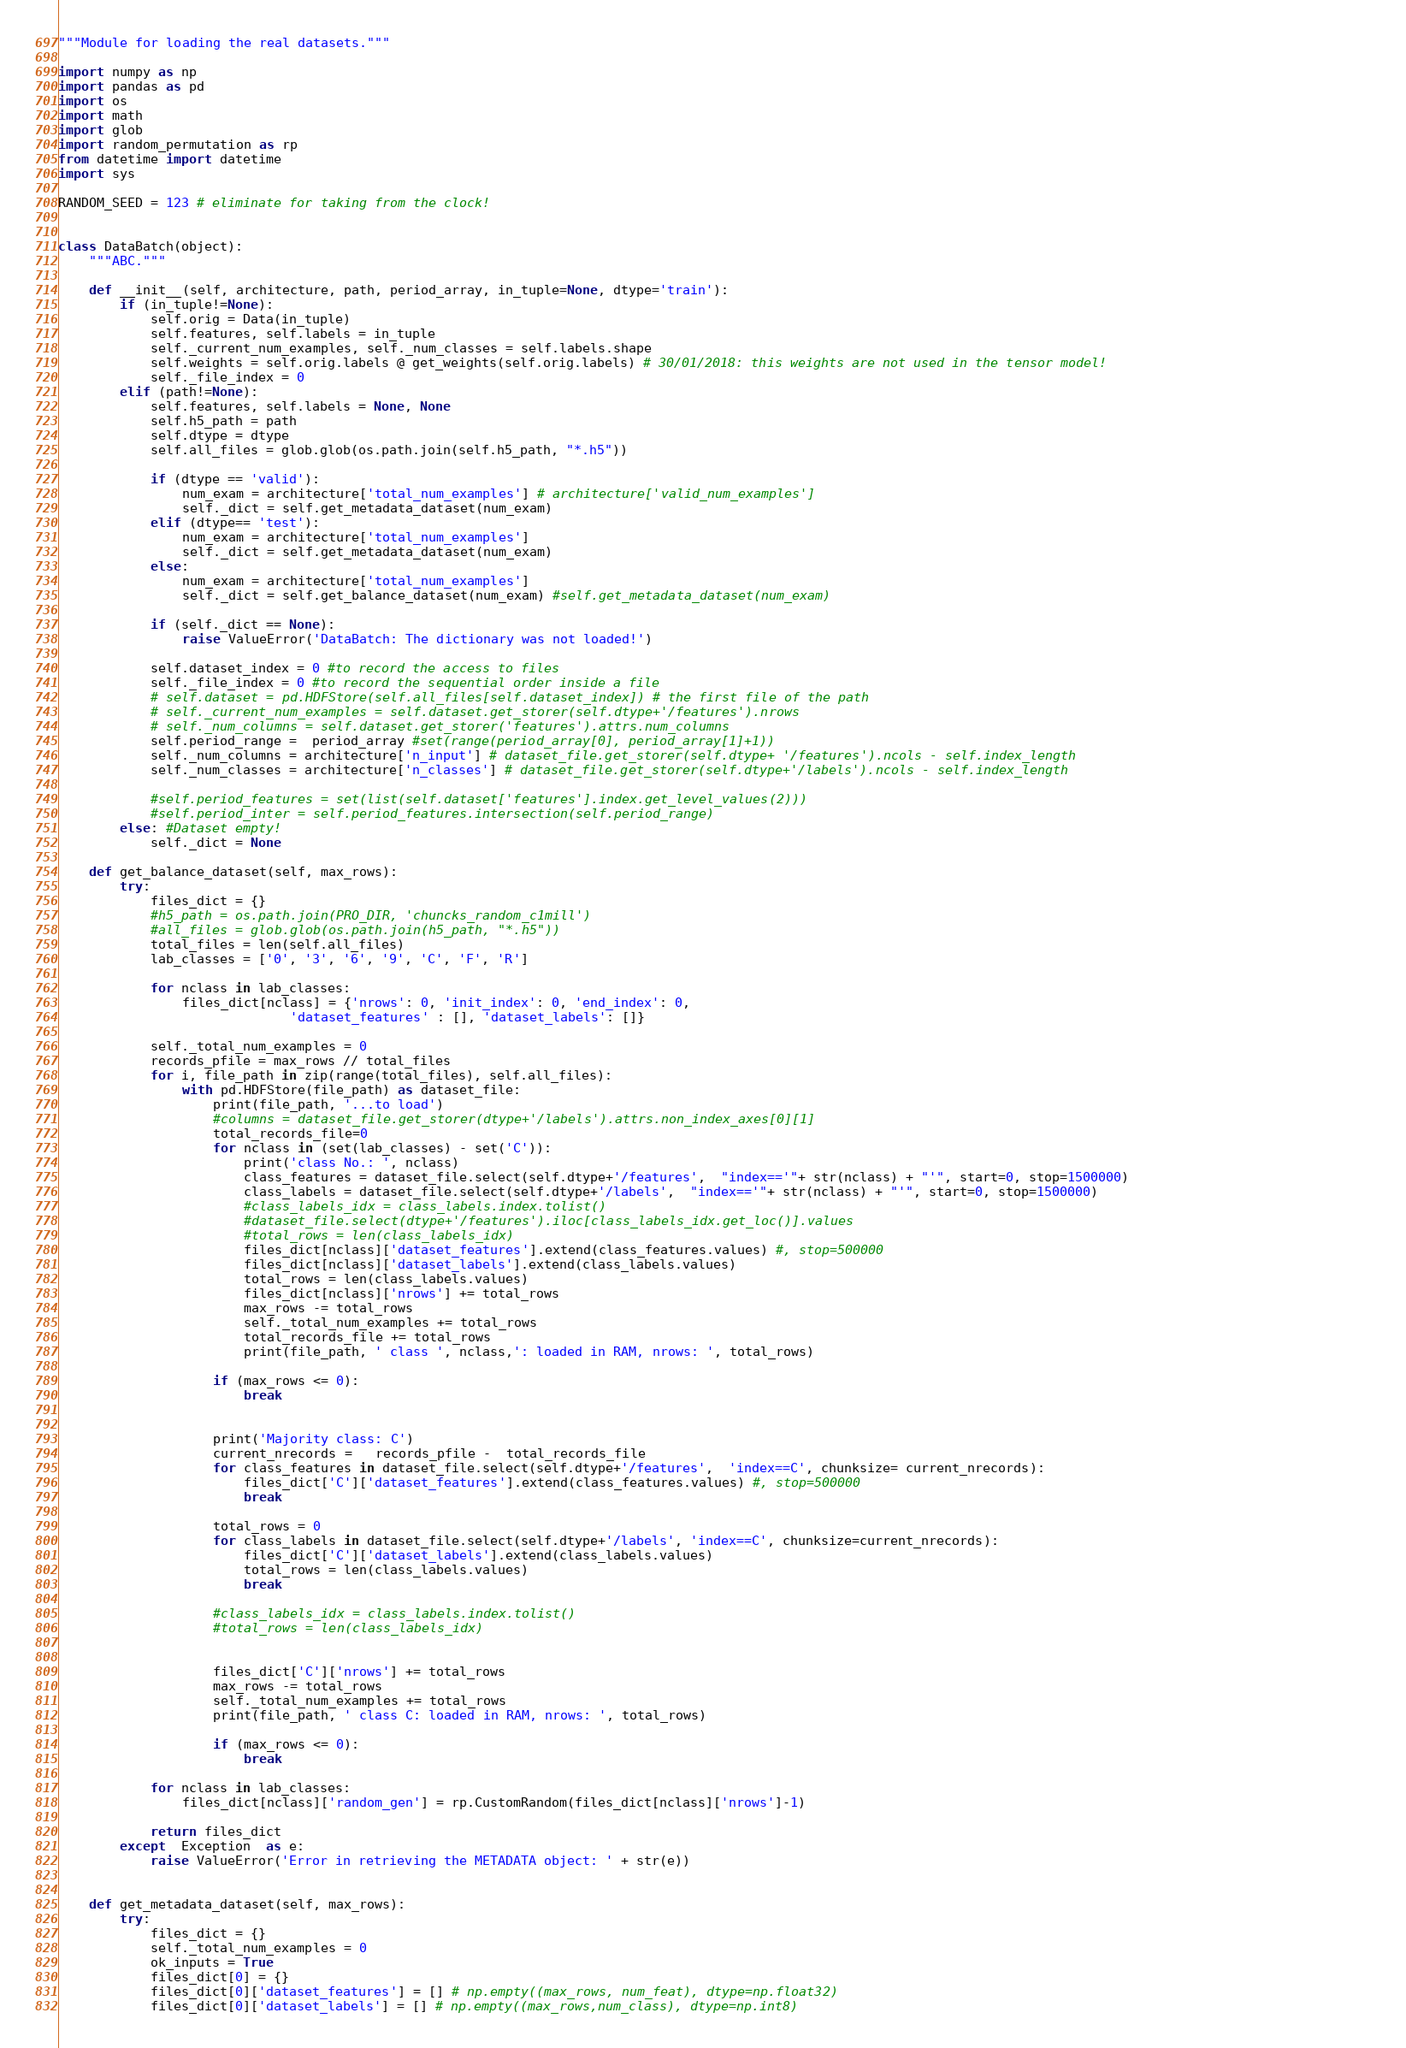Convert code to text. <code><loc_0><loc_0><loc_500><loc_500><_Python_>"""Module for loading the real datasets."""

import numpy as np
import pandas as pd
import os
import math
import glob
import random_permutation as rp
from datetime import datetime
import sys

RANDOM_SEED = 123 # eliminate for taking from the clock!


class DataBatch(object):
    """ABC."""

    def __init__(self, architecture, path, period_array, in_tuple=None, dtype='train'):
        if (in_tuple!=None):
            self.orig = Data(in_tuple)
            self.features, self.labels = in_tuple
            self._current_num_examples, self._num_classes = self.labels.shape        
            self.weights = self.orig.labels @ get_weights(self.orig.labels) # 30/01/2018: this weights are not used in the tensor model!
            self._file_index = 0            
        elif (path!=None):            
            self.features, self.labels = None, None
            self.h5_path = path
            self.dtype = dtype            
            self.all_files = glob.glob(os.path.join(self.h5_path, "*.h5"))    

            if (dtype == 'valid'):
                num_exam = architecture['total_num_examples'] # architecture['valid_num_examples']
                self._dict = self.get_metadata_dataset(num_exam)
            elif (dtype== 'test'):
                num_exam = architecture['total_num_examples']
                self._dict = self.get_metadata_dataset(num_exam)
            else:
                num_exam = architecture['total_num_examples']
                self._dict = self.get_balance_dataset(num_exam) #self.get_metadata_dataset(num_exam)
                                                
            if (self._dict == None):
                raise ValueError('DataBatch: The dictionary was not loaded!')
                        
            self.dataset_index = 0 #to record the access to files
            self._file_index = 0 #to record the sequential order inside a file               
            # self.dataset = pd.HDFStore(self.all_files[self.dataset_index]) # the first file of the path
            # self._current_num_examples = self.dataset.get_storer(self.dtype+'/features').nrows
            # self._num_columns = self.dataset.get_storer('features').attrs.num_columns
            self.period_range =  period_array #set(range(period_array[0], period_array[1]+1))
            self._num_columns = architecture['n_input'] # dataset_file.get_storer(self.dtype+ '/features').ncols - self.index_length
            self._num_classes = architecture['n_classes'] # dataset_file.get_storer(self.dtype+'/labels').ncols - self.index_length   

            #self.period_features = set(list(self.dataset['features'].index.get_level_values(2)))
            #self.period_inter = self.period_features.intersection(self.period_range)            
        else: #Dataset empty!
            self._dict = None

    def get_balance_dataset(self, max_rows):
        try:                          
            files_dict = {}          
            #h5_path = os.path.join(PRO_DIR, 'chuncks_random_c1mill')
            #all_files = glob.glob(os.path.join(h5_path, "*.h5"))
            total_files = len(self.all_files)            
            lab_classes = ['0', '3', '6', '9', 'C', 'F', 'R']
            
            for nclass in lab_classes:
                files_dict[nclass] = {'nrows': 0, 'init_index': 0, 'end_index': 0,
                              'dataset_features' : [], 'dataset_labels': []}                
                    
            self._total_num_examples = 0
            records_pfile = max_rows // total_files
            for i, file_path in zip(range(total_files), self.all_files):    
                with pd.HDFStore(file_path) as dataset_file:                                
                    print(file_path, '...to load')
                    #columns = dataset_file.get_storer(dtype+'/labels').attrs.non_index_axes[0][1]
                    total_records_file=0
                    for nclass in (set(lab_classes) - set('C')):
                        print('class No.: ', nclass)                       
                        class_features = dataset_file.select(self.dtype+'/features',  "index=='"+ str(nclass) + "'", start=0, stop=1500000)                    
                        class_labels = dataset_file.select(self.dtype+'/labels',  "index=='"+ str(nclass) + "'", start=0, stop=1500000)                    
                        #class_labels_idx = class_labels.index.tolist()
                        #dataset_file.select(dtype+'/features').iloc[class_labels_idx.get_loc()].values
                        #total_rows = len(class_labels_idx)
                        files_dict[nclass]['dataset_features'].extend(class_features.values) #, stop=500000 
                        files_dict[nclass]['dataset_labels'].extend(class_labels.values)
                        total_rows = len(class_labels.values)
                        files_dict[nclass]['nrows'] += total_rows                    
                        max_rows -= total_rows                                                                                                                            
                        self._total_num_examples += total_rows
                        total_records_file += total_rows                    
                        print(file_path, ' class ', nclass,': loaded in RAM, nrows: ', total_rows)                                        
    
                    if (max_rows <= 0):
                        break
                    
    
                    print('Majority class: C')                    
                    current_nrecords =   records_pfile -  total_records_file             
                    for class_features in dataset_file.select(self.dtype+'/features',  'index==C', chunksize= current_nrecords):
                        files_dict['C']['dataset_features'].extend(class_features.values) #, stop=500000     
                        break
                    
                    total_rows = 0
                    for class_labels in dataset_file.select(self.dtype+'/labels', 'index==C', chunksize=current_nrecords):
                        files_dict['C']['dataset_labels'].extend(class_labels.values)
                        total_rows = len(class_labels.values)
                        break
                                        
                    #class_labels_idx = class_labels.index.tolist()
                    #total_rows = len(class_labels_idx)
                    
                    
                    files_dict['C']['nrows'] += total_rows                    
                    max_rows -= total_rows                                                                                                                            
                    self._total_num_examples += total_rows                    
                    print(file_path, ' class C: loaded in RAM, nrows: ', total_rows)
    
                    if (max_rows <= 0):
                        break                

            for nclass in lab_classes:
                files_dict[nclass]['random_gen'] = rp.CustomRandom(files_dict[nclass]['nrows']-1) 
                
            return files_dict        
        except  Exception  as e:        
            raise ValueError('Error in retrieving the METADATA object: ' + str(e))            
    
            
    def get_metadata_dataset(self, max_rows):
        try:                          
            files_dict = {}  
            self._total_num_examples = 0
            ok_inputs = True
            files_dict[0] = {}
            files_dict[0]['dataset_features'] = [] # np.empty((max_rows, num_feat), dtype=np.float32)
            files_dict[0]['dataset_labels'] = [] # np.empty((max_rows,num_class), dtype=np.int8)            </code> 